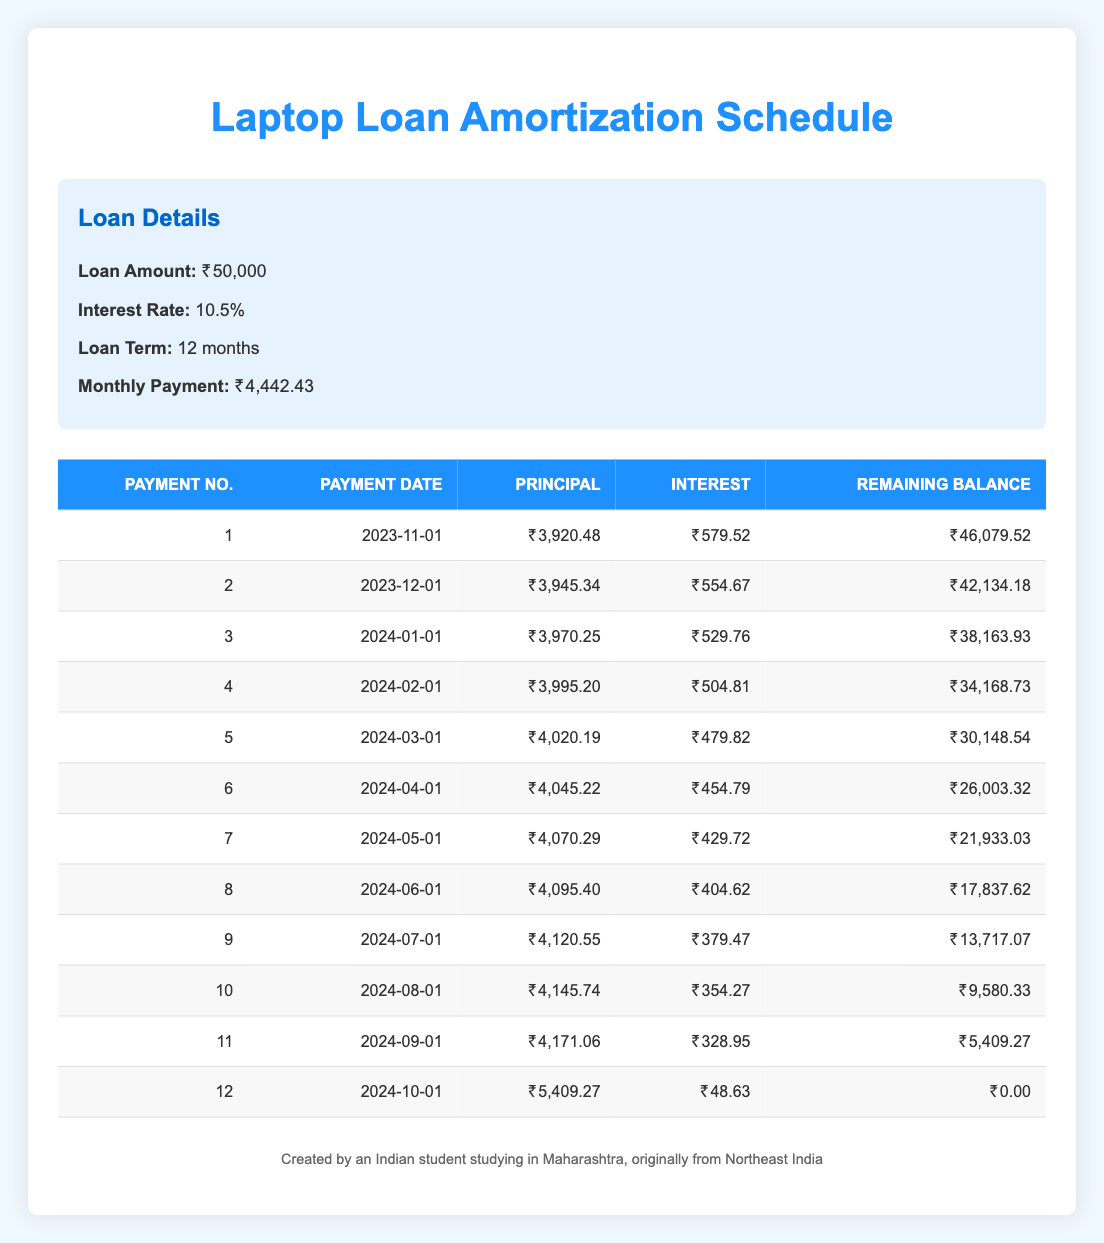What is the total amount paid in the first month? The total payment in the first month is shown in the table as the monthly payment, which is 4,442.43.
Answer: 4,442.43 What is the interest payment in the third month? The table shows the interest payment for the third payment as 529.76.
Answer: 529.76 How much was paid towards the principal by the end of the sixth month? To find the cumulative principal payment by the end of the sixth month, sum the principal payments from the first to the sixth payment: 3920.48 + 3945.34 + 3970.25 + 3995.20 + 4020.19 + 4045.22 =  24,096.68.
Answer: 24,096.68 Do the interest payments increase or decrease over the loan term? By observing the table, the interest payment decreases from 579.52 in the first month to 48.63 in the twelfth month. Thus, interest payments decrease.
Answer: Yes What is the remaining balance after the tenth payment? The table provides the remaining balance after the tenth payment as 9,580.33.
Answer: 9,580.33 What is the average principal payment over the loan term? The average principal payment is calculated by dividing the total principal payments over the 12 months. The total principal paid is 46,120.00 (summation of all principal payments), and dividing by 12 gives 3,843.33 (approximately).
Answer: 3,843.33 How much less was the principal payment in the first month compared to the second month? The principal payment in the first month is 3920.48 and in the second month it's 3945.34. The difference is 3945.34 - 3920.48 = 24.86.
Answer: 24.86 Was the last payment larger than the total of the first two payment amounts? The last payment was 5409.27, and the total of the first two payments is 3920.48 + 3945.34 = 7865.82. Since 5409.27 is less than 7865.82, the statement is false.
Answer: No What is the total interest paid over the loan term? To find the total interest paid, sum all the interest payments from the table: 579.52 + 554.67 + 529.76 + 504.81 + 479.82 + 454.79 + 429.72 + 404.62 + 379.47 + 354.27 + 328.95 + 48.63 = 4142.00.
Answer: 4142.00 